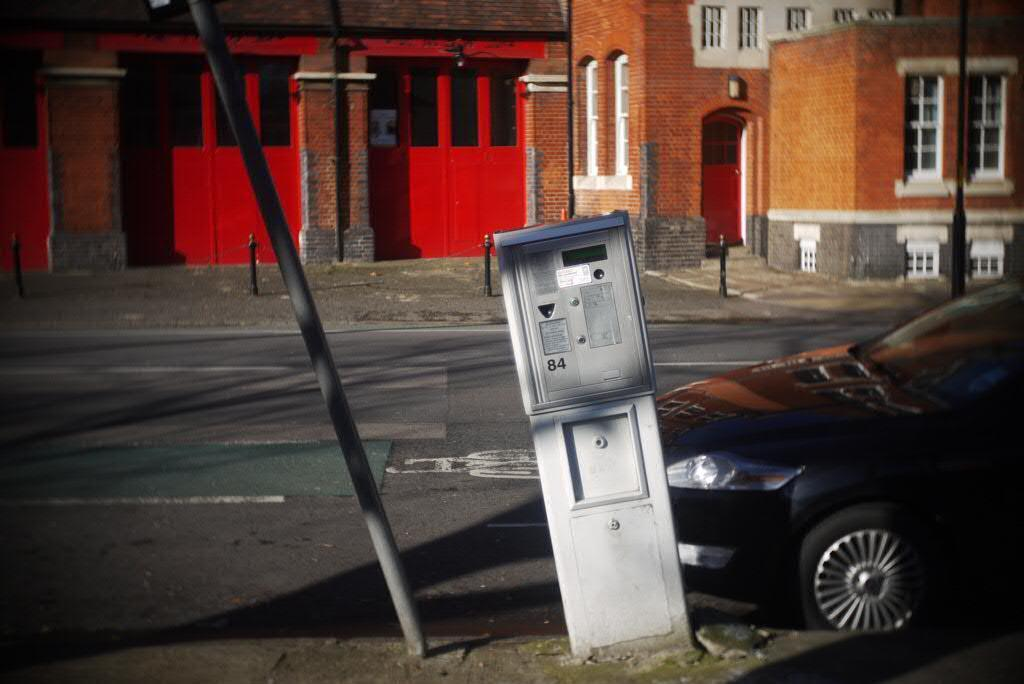What is the main feature of the image? There is a road in the image. What can be seen on the road? There is a car on the road. What structures are present in the image? There are poles, buildings, doors, and windows in the image. Can you see a knife being used by the porter in the image? There is no knife or porter present in the image. Are there any icicles hanging from the buildings in the image? There is no mention of icicles in the provided facts, so we cannot determine if they are present in the image. 